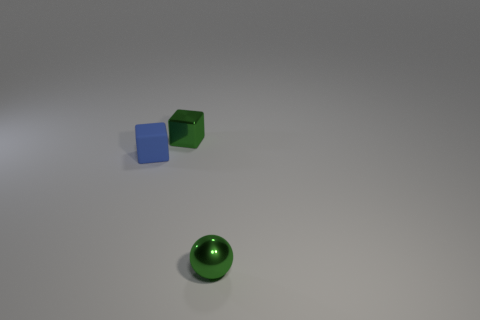Add 1 small gray cylinders. How many objects exist? 4 Subtract 1 cubes. How many cubes are left? 1 Subtract all blue cubes. How many cubes are left? 1 Add 1 blue rubber objects. How many blue rubber objects exist? 2 Subtract 0 purple cylinders. How many objects are left? 3 Subtract all cubes. How many objects are left? 1 Subtract all red spheres. Subtract all green cubes. How many spheres are left? 1 Subtract all tiny green metallic spheres. Subtract all shiny things. How many objects are left? 0 Add 3 blue matte blocks. How many blue matte blocks are left? 4 